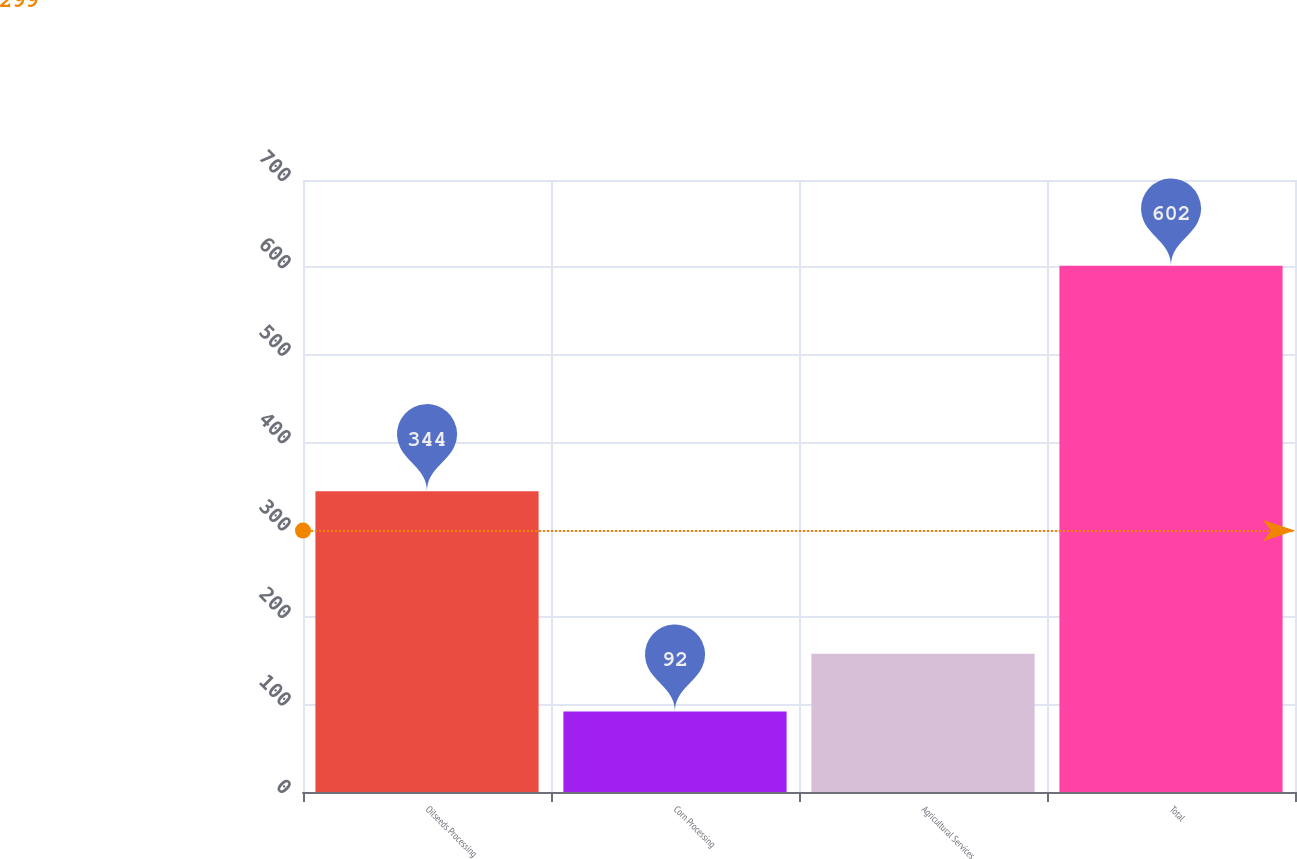Convert chart to OTSL. <chart><loc_0><loc_0><loc_500><loc_500><bar_chart><fcel>Oilseeds Processing<fcel>Corn Processing<fcel>Agricultural Services<fcel>Total<nl><fcel>344<fcel>92<fcel>158<fcel>602<nl></chart> 